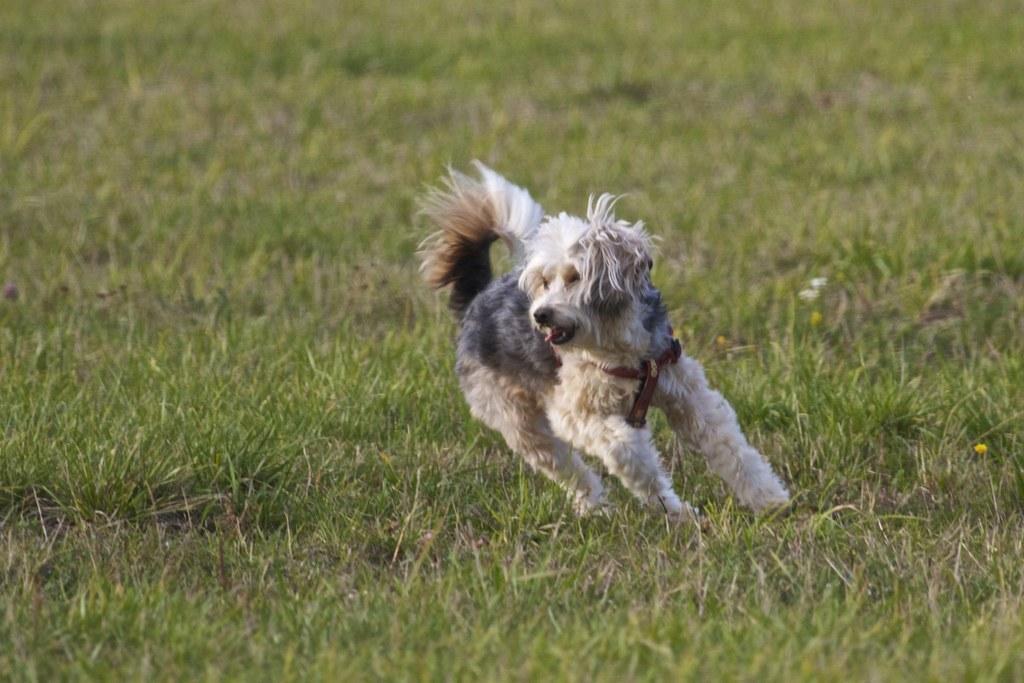How would you summarize this image in a sentence or two? In this image I can see a black and white colour dog is standing. I can also see grass ground and I can see this dog is wearing a brown colour belt. 